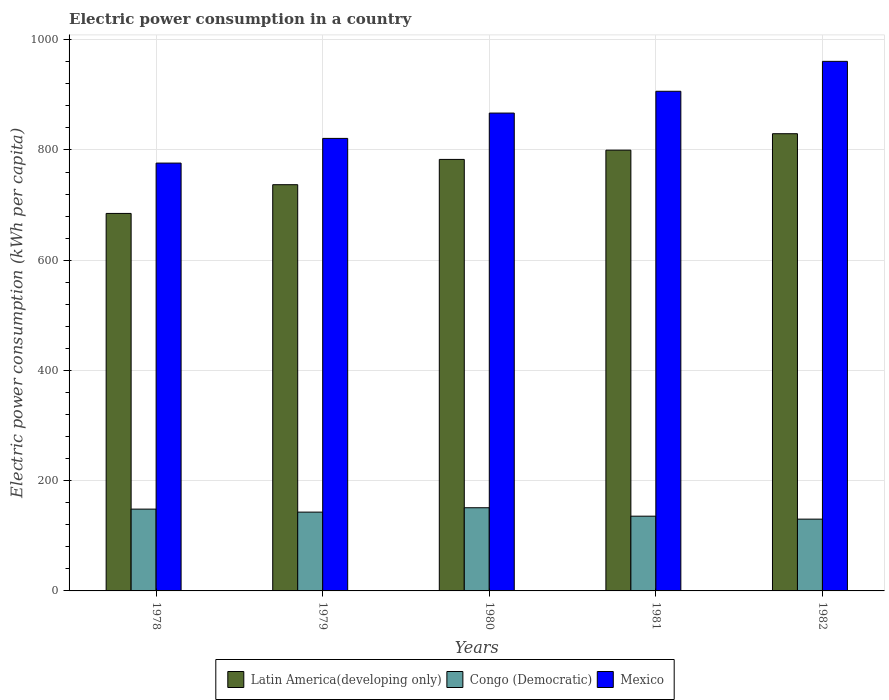Are the number of bars per tick equal to the number of legend labels?
Give a very brief answer. Yes. How many bars are there on the 5th tick from the left?
Give a very brief answer. 3. How many bars are there on the 1st tick from the right?
Offer a terse response. 3. What is the label of the 3rd group of bars from the left?
Your answer should be very brief. 1980. In how many cases, is the number of bars for a given year not equal to the number of legend labels?
Offer a terse response. 0. What is the electric power consumption in in Congo (Democratic) in 1978?
Offer a very short reply. 148.43. Across all years, what is the maximum electric power consumption in in Latin America(developing only)?
Your response must be concise. 829.54. Across all years, what is the minimum electric power consumption in in Mexico?
Provide a succinct answer. 776.24. In which year was the electric power consumption in in Mexico maximum?
Offer a very short reply. 1982. In which year was the electric power consumption in in Latin America(developing only) minimum?
Offer a very short reply. 1978. What is the total electric power consumption in in Latin America(developing only) in the graph?
Keep it short and to the point. 3834.06. What is the difference between the electric power consumption in in Congo (Democratic) in 1978 and that in 1981?
Your answer should be compact. 12.82. What is the difference between the electric power consumption in in Congo (Democratic) in 1981 and the electric power consumption in in Latin America(developing only) in 1982?
Ensure brevity in your answer.  -693.93. What is the average electric power consumption in in Mexico per year?
Offer a very short reply. 866.32. In the year 1978, what is the difference between the electric power consumption in in Mexico and electric power consumption in in Latin America(developing only)?
Your response must be concise. 91.35. In how many years, is the electric power consumption in in Congo (Democratic) greater than 640 kWh per capita?
Make the answer very short. 0. What is the ratio of the electric power consumption in in Congo (Democratic) in 1979 to that in 1982?
Your answer should be very brief. 1.1. Is the electric power consumption in in Mexico in 1978 less than that in 1982?
Your answer should be compact. Yes. What is the difference between the highest and the second highest electric power consumption in in Mexico?
Make the answer very short. 54.3. What is the difference between the highest and the lowest electric power consumption in in Congo (Democratic)?
Provide a short and direct response. 20.69. In how many years, is the electric power consumption in in Mexico greater than the average electric power consumption in in Mexico taken over all years?
Keep it short and to the point. 3. What does the 3rd bar from the left in 1982 represents?
Provide a succinct answer. Mexico. What does the 3rd bar from the right in 1978 represents?
Make the answer very short. Latin America(developing only). Is it the case that in every year, the sum of the electric power consumption in in Congo (Democratic) and electric power consumption in in Latin America(developing only) is greater than the electric power consumption in in Mexico?
Give a very brief answer. No. Are all the bars in the graph horizontal?
Provide a succinct answer. No. How many years are there in the graph?
Offer a very short reply. 5. What is the difference between two consecutive major ticks on the Y-axis?
Ensure brevity in your answer.  200. Does the graph contain any zero values?
Make the answer very short. No. Where does the legend appear in the graph?
Ensure brevity in your answer.  Bottom center. What is the title of the graph?
Ensure brevity in your answer.  Electric power consumption in a country. What is the label or title of the Y-axis?
Provide a succinct answer. Electric power consumption (kWh per capita). What is the Electric power consumption (kWh per capita) of Latin America(developing only) in 1978?
Give a very brief answer. 684.89. What is the Electric power consumption (kWh per capita) in Congo (Democratic) in 1978?
Provide a succinct answer. 148.43. What is the Electric power consumption (kWh per capita) in Mexico in 1978?
Provide a succinct answer. 776.24. What is the Electric power consumption (kWh per capita) of Latin America(developing only) in 1979?
Make the answer very short. 737.03. What is the Electric power consumption (kWh per capita) of Congo (Democratic) in 1979?
Provide a short and direct response. 142.97. What is the Electric power consumption (kWh per capita) in Mexico in 1979?
Your answer should be compact. 821.04. What is the Electric power consumption (kWh per capita) of Latin America(developing only) in 1980?
Offer a terse response. 782.89. What is the Electric power consumption (kWh per capita) in Congo (Democratic) in 1980?
Make the answer very short. 150.93. What is the Electric power consumption (kWh per capita) of Mexico in 1980?
Keep it short and to the point. 866.97. What is the Electric power consumption (kWh per capita) of Latin America(developing only) in 1981?
Offer a very short reply. 799.72. What is the Electric power consumption (kWh per capita) in Congo (Democratic) in 1981?
Your answer should be compact. 135.61. What is the Electric power consumption (kWh per capita) in Mexico in 1981?
Offer a very short reply. 906.52. What is the Electric power consumption (kWh per capita) of Latin America(developing only) in 1982?
Give a very brief answer. 829.54. What is the Electric power consumption (kWh per capita) in Congo (Democratic) in 1982?
Offer a terse response. 130.24. What is the Electric power consumption (kWh per capita) of Mexico in 1982?
Offer a very short reply. 960.81. Across all years, what is the maximum Electric power consumption (kWh per capita) in Latin America(developing only)?
Give a very brief answer. 829.54. Across all years, what is the maximum Electric power consumption (kWh per capita) in Congo (Democratic)?
Provide a succinct answer. 150.93. Across all years, what is the maximum Electric power consumption (kWh per capita) of Mexico?
Your answer should be very brief. 960.81. Across all years, what is the minimum Electric power consumption (kWh per capita) in Latin America(developing only)?
Make the answer very short. 684.89. Across all years, what is the minimum Electric power consumption (kWh per capita) of Congo (Democratic)?
Offer a very short reply. 130.24. Across all years, what is the minimum Electric power consumption (kWh per capita) in Mexico?
Your answer should be compact. 776.24. What is the total Electric power consumption (kWh per capita) of Latin America(developing only) in the graph?
Give a very brief answer. 3834.06. What is the total Electric power consumption (kWh per capita) in Congo (Democratic) in the graph?
Your answer should be compact. 708.16. What is the total Electric power consumption (kWh per capita) of Mexico in the graph?
Your answer should be very brief. 4331.58. What is the difference between the Electric power consumption (kWh per capita) in Latin America(developing only) in 1978 and that in 1979?
Give a very brief answer. -52.13. What is the difference between the Electric power consumption (kWh per capita) of Congo (Democratic) in 1978 and that in 1979?
Offer a very short reply. 5.46. What is the difference between the Electric power consumption (kWh per capita) of Mexico in 1978 and that in 1979?
Keep it short and to the point. -44.8. What is the difference between the Electric power consumption (kWh per capita) in Latin America(developing only) in 1978 and that in 1980?
Keep it short and to the point. -98. What is the difference between the Electric power consumption (kWh per capita) in Congo (Democratic) in 1978 and that in 1980?
Give a very brief answer. -2.5. What is the difference between the Electric power consumption (kWh per capita) of Mexico in 1978 and that in 1980?
Provide a short and direct response. -90.73. What is the difference between the Electric power consumption (kWh per capita) in Latin America(developing only) in 1978 and that in 1981?
Offer a very short reply. -114.83. What is the difference between the Electric power consumption (kWh per capita) in Congo (Democratic) in 1978 and that in 1981?
Your answer should be very brief. 12.82. What is the difference between the Electric power consumption (kWh per capita) in Mexico in 1978 and that in 1981?
Offer a terse response. -130.27. What is the difference between the Electric power consumption (kWh per capita) in Latin America(developing only) in 1978 and that in 1982?
Provide a short and direct response. -144.64. What is the difference between the Electric power consumption (kWh per capita) of Congo (Democratic) in 1978 and that in 1982?
Provide a short and direct response. 18.19. What is the difference between the Electric power consumption (kWh per capita) in Mexico in 1978 and that in 1982?
Your answer should be compact. -184.57. What is the difference between the Electric power consumption (kWh per capita) in Latin America(developing only) in 1979 and that in 1980?
Offer a very short reply. -45.86. What is the difference between the Electric power consumption (kWh per capita) of Congo (Democratic) in 1979 and that in 1980?
Offer a terse response. -7.96. What is the difference between the Electric power consumption (kWh per capita) in Mexico in 1979 and that in 1980?
Your response must be concise. -45.93. What is the difference between the Electric power consumption (kWh per capita) in Latin America(developing only) in 1979 and that in 1981?
Keep it short and to the point. -62.69. What is the difference between the Electric power consumption (kWh per capita) of Congo (Democratic) in 1979 and that in 1981?
Offer a very short reply. 7.36. What is the difference between the Electric power consumption (kWh per capita) in Mexico in 1979 and that in 1981?
Keep it short and to the point. -85.48. What is the difference between the Electric power consumption (kWh per capita) in Latin America(developing only) in 1979 and that in 1982?
Offer a terse response. -92.51. What is the difference between the Electric power consumption (kWh per capita) in Congo (Democratic) in 1979 and that in 1982?
Offer a very short reply. 12.73. What is the difference between the Electric power consumption (kWh per capita) of Mexico in 1979 and that in 1982?
Offer a terse response. -139.77. What is the difference between the Electric power consumption (kWh per capita) of Latin America(developing only) in 1980 and that in 1981?
Your answer should be compact. -16.83. What is the difference between the Electric power consumption (kWh per capita) of Congo (Democratic) in 1980 and that in 1981?
Your answer should be very brief. 15.32. What is the difference between the Electric power consumption (kWh per capita) in Mexico in 1980 and that in 1981?
Your response must be concise. -39.54. What is the difference between the Electric power consumption (kWh per capita) of Latin America(developing only) in 1980 and that in 1982?
Make the answer very short. -46.65. What is the difference between the Electric power consumption (kWh per capita) of Congo (Democratic) in 1980 and that in 1982?
Your answer should be very brief. 20.69. What is the difference between the Electric power consumption (kWh per capita) of Mexico in 1980 and that in 1982?
Your response must be concise. -93.84. What is the difference between the Electric power consumption (kWh per capita) in Latin America(developing only) in 1981 and that in 1982?
Ensure brevity in your answer.  -29.82. What is the difference between the Electric power consumption (kWh per capita) of Congo (Democratic) in 1981 and that in 1982?
Your answer should be very brief. 5.37. What is the difference between the Electric power consumption (kWh per capita) of Mexico in 1981 and that in 1982?
Provide a succinct answer. -54.3. What is the difference between the Electric power consumption (kWh per capita) of Latin America(developing only) in 1978 and the Electric power consumption (kWh per capita) of Congo (Democratic) in 1979?
Your response must be concise. 541.93. What is the difference between the Electric power consumption (kWh per capita) in Latin America(developing only) in 1978 and the Electric power consumption (kWh per capita) in Mexico in 1979?
Ensure brevity in your answer.  -136.15. What is the difference between the Electric power consumption (kWh per capita) in Congo (Democratic) in 1978 and the Electric power consumption (kWh per capita) in Mexico in 1979?
Ensure brevity in your answer.  -672.61. What is the difference between the Electric power consumption (kWh per capita) of Latin America(developing only) in 1978 and the Electric power consumption (kWh per capita) of Congo (Democratic) in 1980?
Make the answer very short. 533.97. What is the difference between the Electric power consumption (kWh per capita) of Latin America(developing only) in 1978 and the Electric power consumption (kWh per capita) of Mexico in 1980?
Ensure brevity in your answer.  -182.08. What is the difference between the Electric power consumption (kWh per capita) in Congo (Democratic) in 1978 and the Electric power consumption (kWh per capita) in Mexico in 1980?
Your answer should be very brief. -718.54. What is the difference between the Electric power consumption (kWh per capita) in Latin America(developing only) in 1978 and the Electric power consumption (kWh per capita) in Congo (Democratic) in 1981?
Your response must be concise. 549.29. What is the difference between the Electric power consumption (kWh per capita) in Latin America(developing only) in 1978 and the Electric power consumption (kWh per capita) in Mexico in 1981?
Offer a terse response. -221.62. What is the difference between the Electric power consumption (kWh per capita) in Congo (Democratic) in 1978 and the Electric power consumption (kWh per capita) in Mexico in 1981?
Make the answer very short. -758.09. What is the difference between the Electric power consumption (kWh per capita) of Latin America(developing only) in 1978 and the Electric power consumption (kWh per capita) of Congo (Democratic) in 1982?
Make the answer very short. 554.65. What is the difference between the Electric power consumption (kWh per capita) of Latin America(developing only) in 1978 and the Electric power consumption (kWh per capita) of Mexico in 1982?
Keep it short and to the point. -275.92. What is the difference between the Electric power consumption (kWh per capita) in Congo (Democratic) in 1978 and the Electric power consumption (kWh per capita) in Mexico in 1982?
Give a very brief answer. -812.38. What is the difference between the Electric power consumption (kWh per capita) in Latin America(developing only) in 1979 and the Electric power consumption (kWh per capita) in Congo (Democratic) in 1980?
Provide a succinct answer. 586.1. What is the difference between the Electric power consumption (kWh per capita) of Latin America(developing only) in 1979 and the Electric power consumption (kWh per capita) of Mexico in 1980?
Make the answer very short. -129.95. What is the difference between the Electric power consumption (kWh per capita) of Congo (Democratic) in 1979 and the Electric power consumption (kWh per capita) of Mexico in 1980?
Give a very brief answer. -724.01. What is the difference between the Electric power consumption (kWh per capita) in Latin America(developing only) in 1979 and the Electric power consumption (kWh per capita) in Congo (Democratic) in 1981?
Offer a very short reply. 601.42. What is the difference between the Electric power consumption (kWh per capita) of Latin America(developing only) in 1979 and the Electric power consumption (kWh per capita) of Mexico in 1981?
Offer a terse response. -169.49. What is the difference between the Electric power consumption (kWh per capita) in Congo (Democratic) in 1979 and the Electric power consumption (kWh per capita) in Mexico in 1981?
Your answer should be compact. -763.55. What is the difference between the Electric power consumption (kWh per capita) of Latin America(developing only) in 1979 and the Electric power consumption (kWh per capita) of Congo (Democratic) in 1982?
Keep it short and to the point. 606.79. What is the difference between the Electric power consumption (kWh per capita) in Latin America(developing only) in 1979 and the Electric power consumption (kWh per capita) in Mexico in 1982?
Offer a terse response. -223.79. What is the difference between the Electric power consumption (kWh per capita) of Congo (Democratic) in 1979 and the Electric power consumption (kWh per capita) of Mexico in 1982?
Give a very brief answer. -817.85. What is the difference between the Electric power consumption (kWh per capita) in Latin America(developing only) in 1980 and the Electric power consumption (kWh per capita) in Congo (Democratic) in 1981?
Your answer should be compact. 647.28. What is the difference between the Electric power consumption (kWh per capita) of Latin America(developing only) in 1980 and the Electric power consumption (kWh per capita) of Mexico in 1981?
Offer a terse response. -123.63. What is the difference between the Electric power consumption (kWh per capita) of Congo (Democratic) in 1980 and the Electric power consumption (kWh per capita) of Mexico in 1981?
Provide a succinct answer. -755.59. What is the difference between the Electric power consumption (kWh per capita) in Latin America(developing only) in 1980 and the Electric power consumption (kWh per capita) in Congo (Democratic) in 1982?
Provide a short and direct response. 652.65. What is the difference between the Electric power consumption (kWh per capita) in Latin America(developing only) in 1980 and the Electric power consumption (kWh per capita) in Mexico in 1982?
Your answer should be compact. -177.92. What is the difference between the Electric power consumption (kWh per capita) of Congo (Democratic) in 1980 and the Electric power consumption (kWh per capita) of Mexico in 1982?
Make the answer very short. -809.89. What is the difference between the Electric power consumption (kWh per capita) in Latin America(developing only) in 1981 and the Electric power consumption (kWh per capita) in Congo (Democratic) in 1982?
Keep it short and to the point. 669.48. What is the difference between the Electric power consumption (kWh per capita) in Latin America(developing only) in 1981 and the Electric power consumption (kWh per capita) in Mexico in 1982?
Your answer should be very brief. -161.09. What is the difference between the Electric power consumption (kWh per capita) of Congo (Democratic) in 1981 and the Electric power consumption (kWh per capita) of Mexico in 1982?
Offer a very short reply. -825.21. What is the average Electric power consumption (kWh per capita) in Latin America(developing only) per year?
Keep it short and to the point. 766.81. What is the average Electric power consumption (kWh per capita) of Congo (Democratic) per year?
Your response must be concise. 141.63. What is the average Electric power consumption (kWh per capita) in Mexico per year?
Offer a terse response. 866.32. In the year 1978, what is the difference between the Electric power consumption (kWh per capita) in Latin America(developing only) and Electric power consumption (kWh per capita) in Congo (Democratic)?
Your answer should be very brief. 536.46. In the year 1978, what is the difference between the Electric power consumption (kWh per capita) in Latin America(developing only) and Electric power consumption (kWh per capita) in Mexico?
Keep it short and to the point. -91.35. In the year 1978, what is the difference between the Electric power consumption (kWh per capita) in Congo (Democratic) and Electric power consumption (kWh per capita) in Mexico?
Your answer should be compact. -627.82. In the year 1979, what is the difference between the Electric power consumption (kWh per capita) of Latin America(developing only) and Electric power consumption (kWh per capita) of Congo (Democratic)?
Your answer should be very brief. 594.06. In the year 1979, what is the difference between the Electric power consumption (kWh per capita) of Latin America(developing only) and Electric power consumption (kWh per capita) of Mexico?
Provide a short and direct response. -84.02. In the year 1979, what is the difference between the Electric power consumption (kWh per capita) of Congo (Democratic) and Electric power consumption (kWh per capita) of Mexico?
Give a very brief answer. -678.07. In the year 1980, what is the difference between the Electric power consumption (kWh per capita) of Latin America(developing only) and Electric power consumption (kWh per capita) of Congo (Democratic)?
Your answer should be very brief. 631.96. In the year 1980, what is the difference between the Electric power consumption (kWh per capita) of Latin America(developing only) and Electric power consumption (kWh per capita) of Mexico?
Offer a very short reply. -84.08. In the year 1980, what is the difference between the Electric power consumption (kWh per capita) of Congo (Democratic) and Electric power consumption (kWh per capita) of Mexico?
Make the answer very short. -716.05. In the year 1981, what is the difference between the Electric power consumption (kWh per capita) in Latin America(developing only) and Electric power consumption (kWh per capita) in Congo (Democratic)?
Your answer should be very brief. 664.11. In the year 1981, what is the difference between the Electric power consumption (kWh per capita) of Latin America(developing only) and Electric power consumption (kWh per capita) of Mexico?
Your answer should be compact. -106.8. In the year 1981, what is the difference between the Electric power consumption (kWh per capita) of Congo (Democratic) and Electric power consumption (kWh per capita) of Mexico?
Provide a succinct answer. -770.91. In the year 1982, what is the difference between the Electric power consumption (kWh per capita) in Latin America(developing only) and Electric power consumption (kWh per capita) in Congo (Democratic)?
Offer a very short reply. 699.3. In the year 1982, what is the difference between the Electric power consumption (kWh per capita) of Latin America(developing only) and Electric power consumption (kWh per capita) of Mexico?
Keep it short and to the point. -131.28. In the year 1982, what is the difference between the Electric power consumption (kWh per capita) of Congo (Democratic) and Electric power consumption (kWh per capita) of Mexico?
Provide a short and direct response. -830.57. What is the ratio of the Electric power consumption (kWh per capita) in Latin America(developing only) in 1978 to that in 1979?
Give a very brief answer. 0.93. What is the ratio of the Electric power consumption (kWh per capita) of Congo (Democratic) in 1978 to that in 1979?
Provide a succinct answer. 1.04. What is the ratio of the Electric power consumption (kWh per capita) in Mexico in 1978 to that in 1979?
Your response must be concise. 0.95. What is the ratio of the Electric power consumption (kWh per capita) of Latin America(developing only) in 1978 to that in 1980?
Provide a succinct answer. 0.87. What is the ratio of the Electric power consumption (kWh per capita) in Congo (Democratic) in 1978 to that in 1980?
Your response must be concise. 0.98. What is the ratio of the Electric power consumption (kWh per capita) of Mexico in 1978 to that in 1980?
Offer a terse response. 0.9. What is the ratio of the Electric power consumption (kWh per capita) of Latin America(developing only) in 1978 to that in 1981?
Provide a short and direct response. 0.86. What is the ratio of the Electric power consumption (kWh per capita) of Congo (Democratic) in 1978 to that in 1981?
Your answer should be very brief. 1.09. What is the ratio of the Electric power consumption (kWh per capita) in Mexico in 1978 to that in 1981?
Make the answer very short. 0.86. What is the ratio of the Electric power consumption (kWh per capita) of Latin America(developing only) in 1978 to that in 1982?
Provide a short and direct response. 0.83. What is the ratio of the Electric power consumption (kWh per capita) in Congo (Democratic) in 1978 to that in 1982?
Ensure brevity in your answer.  1.14. What is the ratio of the Electric power consumption (kWh per capita) of Mexico in 1978 to that in 1982?
Give a very brief answer. 0.81. What is the ratio of the Electric power consumption (kWh per capita) of Latin America(developing only) in 1979 to that in 1980?
Keep it short and to the point. 0.94. What is the ratio of the Electric power consumption (kWh per capita) in Congo (Democratic) in 1979 to that in 1980?
Provide a succinct answer. 0.95. What is the ratio of the Electric power consumption (kWh per capita) in Mexico in 1979 to that in 1980?
Your answer should be compact. 0.95. What is the ratio of the Electric power consumption (kWh per capita) of Latin America(developing only) in 1979 to that in 1981?
Offer a terse response. 0.92. What is the ratio of the Electric power consumption (kWh per capita) in Congo (Democratic) in 1979 to that in 1981?
Offer a terse response. 1.05. What is the ratio of the Electric power consumption (kWh per capita) in Mexico in 1979 to that in 1981?
Keep it short and to the point. 0.91. What is the ratio of the Electric power consumption (kWh per capita) in Latin America(developing only) in 1979 to that in 1982?
Ensure brevity in your answer.  0.89. What is the ratio of the Electric power consumption (kWh per capita) in Congo (Democratic) in 1979 to that in 1982?
Provide a short and direct response. 1.1. What is the ratio of the Electric power consumption (kWh per capita) in Mexico in 1979 to that in 1982?
Give a very brief answer. 0.85. What is the ratio of the Electric power consumption (kWh per capita) in Congo (Democratic) in 1980 to that in 1981?
Provide a succinct answer. 1.11. What is the ratio of the Electric power consumption (kWh per capita) in Mexico in 1980 to that in 1981?
Your answer should be very brief. 0.96. What is the ratio of the Electric power consumption (kWh per capita) in Latin America(developing only) in 1980 to that in 1982?
Give a very brief answer. 0.94. What is the ratio of the Electric power consumption (kWh per capita) of Congo (Democratic) in 1980 to that in 1982?
Offer a terse response. 1.16. What is the ratio of the Electric power consumption (kWh per capita) in Mexico in 1980 to that in 1982?
Your answer should be very brief. 0.9. What is the ratio of the Electric power consumption (kWh per capita) of Latin America(developing only) in 1981 to that in 1982?
Your answer should be very brief. 0.96. What is the ratio of the Electric power consumption (kWh per capita) of Congo (Democratic) in 1981 to that in 1982?
Provide a succinct answer. 1.04. What is the ratio of the Electric power consumption (kWh per capita) in Mexico in 1981 to that in 1982?
Your answer should be compact. 0.94. What is the difference between the highest and the second highest Electric power consumption (kWh per capita) in Latin America(developing only)?
Keep it short and to the point. 29.82. What is the difference between the highest and the second highest Electric power consumption (kWh per capita) in Congo (Democratic)?
Your answer should be very brief. 2.5. What is the difference between the highest and the second highest Electric power consumption (kWh per capita) of Mexico?
Offer a very short reply. 54.3. What is the difference between the highest and the lowest Electric power consumption (kWh per capita) in Latin America(developing only)?
Your answer should be very brief. 144.64. What is the difference between the highest and the lowest Electric power consumption (kWh per capita) of Congo (Democratic)?
Keep it short and to the point. 20.69. What is the difference between the highest and the lowest Electric power consumption (kWh per capita) in Mexico?
Give a very brief answer. 184.57. 